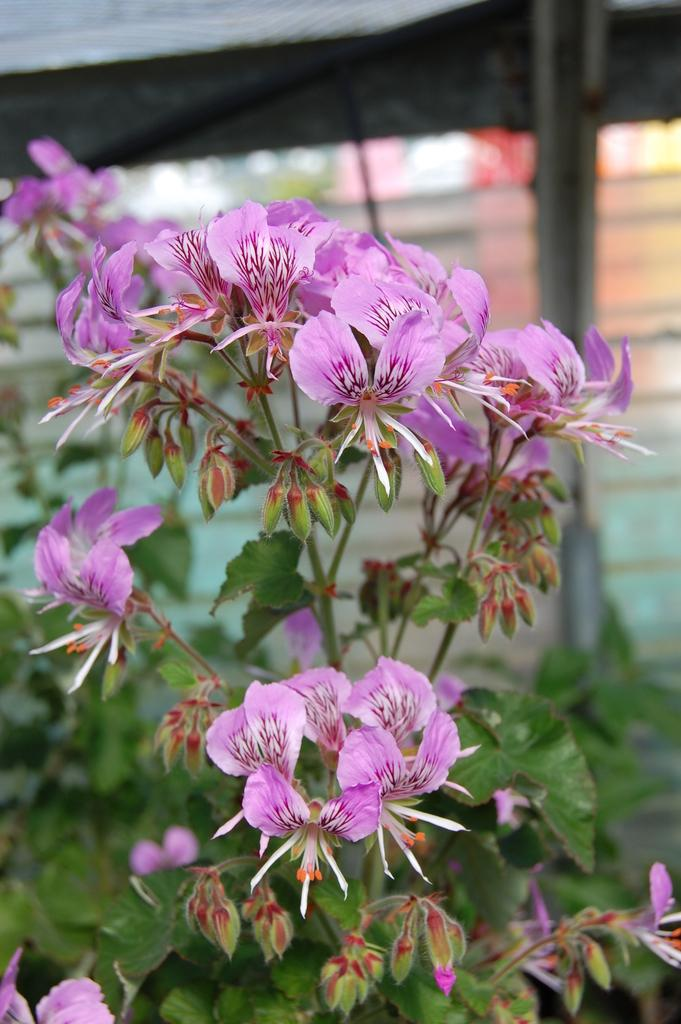What type of plant life is present in the image? There are flowers in the image. What parts of the flowers are visible? The flowers have leaves and stems. How would you describe the background of the image? The background of the image is blurred. What else can be seen in the image besides the flowers? Leaves are visible in the image, as well as a rod and a glass. What type of stone can be seen in the image? There is no stone present in the image. What kind of beast is interacting with the flowers in the image? There is no beast present in the image. 